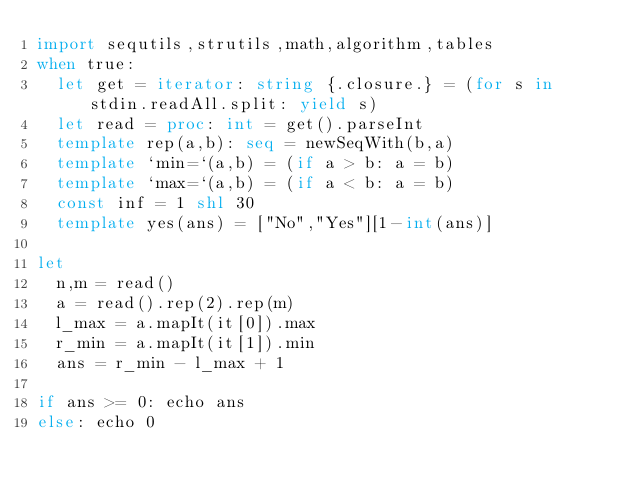Convert code to text. <code><loc_0><loc_0><loc_500><loc_500><_Nim_>import sequtils,strutils,math,algorithm,tables
when true:
  let get = iterator: string {.closure.} = (for s in stdin.readAll.split: yield s)
  let read = proc: int = get().parseInt
  template rep(a,b): seq = newSeqWith(b,a)
  template `min=`(a,b) = (if a > b: a = b)
  template `max=`(a,b) = (if a < b: a = b)
  const inf = 1 shl 30
  template yes(ans) = ["No","Yes"][1-int(ans)]

let
  n,m = read()
  a = read().rep(2).rep(m)
  l_max = a.mapIt(it[0]).max
  r_min = a.mapIt(it[1]).min
  ans = r_min - l_max + 1

if ans >= 0: echo ans
else: echo 0
</code> 